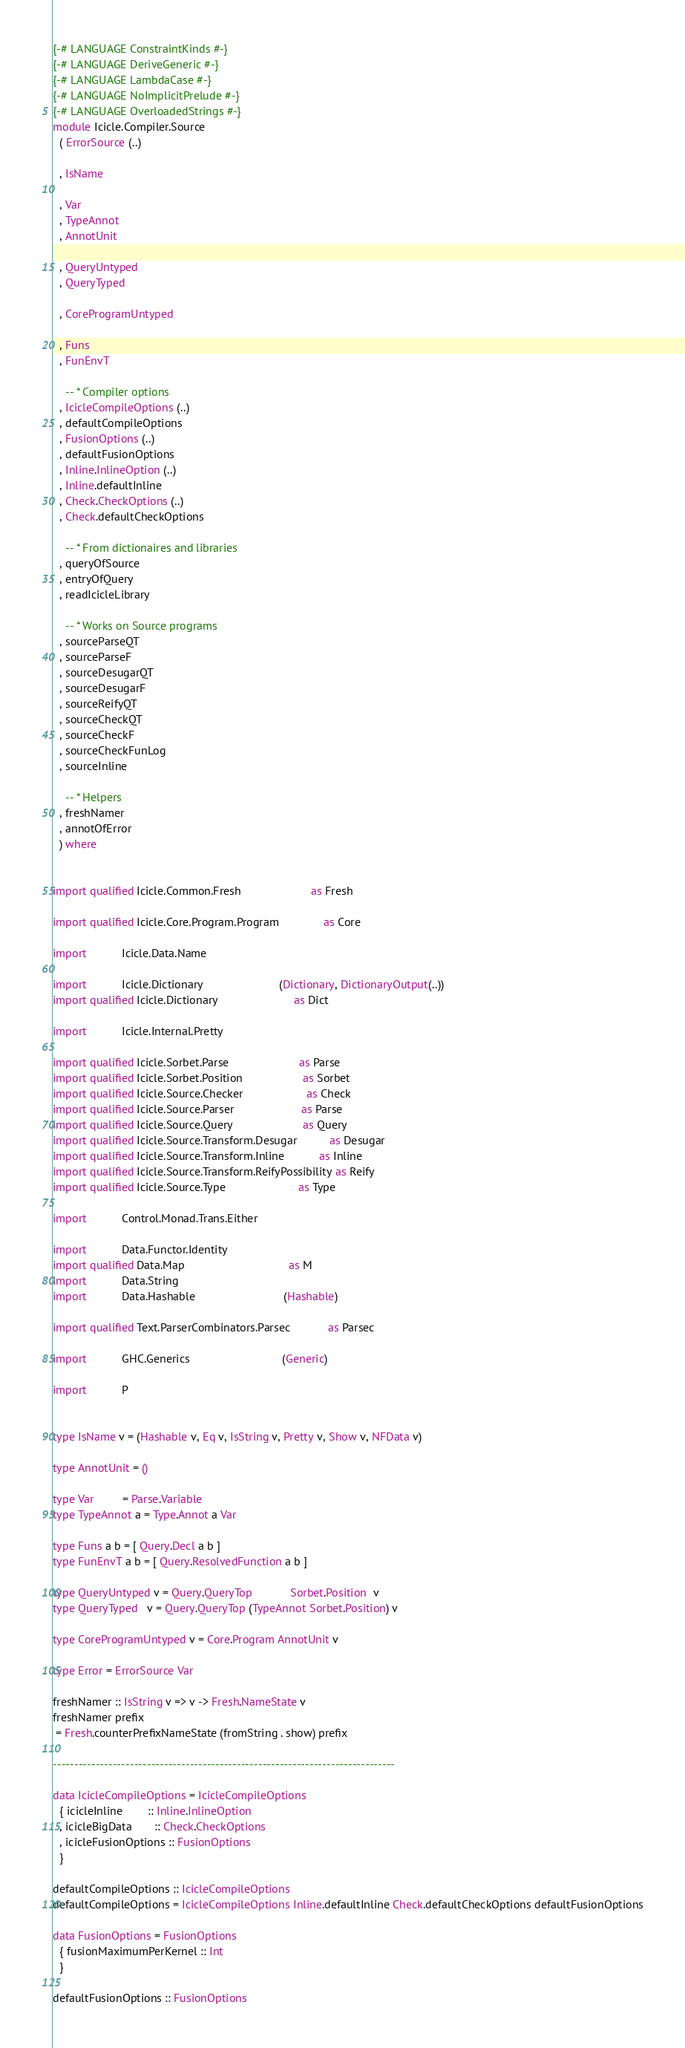Convert code to text. <code><loc_0><loc_0><loc_500><loc_500><_Haskell_>{-# LANGUAGE ConstraintKinds #-}
{-# LANGUAGE DeriveGeneric #-}
{-# LANGUAGE LambdaCase #-}
{-# LANGUAGE NoImplicitPrelude #-}
{-# LANGUAGE OverloadedStrings #-}
module Icicle.Compiler.Source
  ( ErrorSource (..)

  , IsName

  , Var
  , TypeAnnot
  , AnnotUnit

  , QueryUntyped
  , QueryTyped

  , CoreProgramUntyped

  , Funs
  , FunEnvT

    -- * Compiler options
  , IcicleCompileOptions (..)
  , defaultCompileOptions
  , FusionOptions (..)
  , defaultFusionOptions
  , Inline.InlineOption (..)
  , Inline.defaultInline
  , Check.CheckOptions (..)
  , Check.defaultCheckOptions

    -- * From dictionaires and libraries
  , queryOfSource
  , entryOfQuery
  , readIcicleLibrary

    -- * Works on Source programs
  , sourceParseQT
  , sourceParseF
  , sourceDesugarQT
  , sourceDesugarF
  , sourceReifyQT
  , sourceCheckQT
  , sourceCheckF
  , sourceCheckFunLog
  , sourceInline

    -- * Helpers
  , freshNamer
  , annotOfError
  ) where


import qualified Icicle.Common.Fresh                      as Fresh

import qualified Icicle.Core.Program.Program              as Core

import           Icicle.Data.Name

import           Icicle.Dictionary                        (Dictionary, DictionaryOutput(..))
import qualified Icicle.Dictionary                        as Dict

import           Icicle.Internal.Pretty

import qualified Icicle.Sorbet.Parse                      as Parse
import qualified Icicle.Sorbet.Position                   as Sorbet
import qualified Icicle.Source.Checker                    as Check
import qualified Icicle.Source.Parser                     as Parse
import qualified Icicle.Source.Query                      as Query
import qualified Icicle.Source.Transform.Desugar          as Desugar
import qualified Icicle.Source.Transform.Inline           as Inline
import qualified Icicle.Source.Transform.ReifyPossibility as Reify
import qualified Icicle.Source.Type                       as Type

import           Control.Monad.Trans.Either

import           Data.Functor.Identity
import qualified Data.Map                                 as M
import           Data.String
import           Data.Hashable                            (Hashable)

import qualified Text.ParserCombinators.Parsec            as Parsec

import           GHC.Generics                             (Generic)

import           P


type IsName v = (Hashable v, Eq v, IsString v, Pretty v, Show v, NFData v)

type AnnotUnit = ()

type Var         = Parse.Variable
type TypeAnnot a = Type.Annot a Var

type Funs a b = [ Query.Decl a b ]
type FunEnvT a b = [ Query.ResolvedFunction a b ]

type QueryUntyped v = Query.QueryTop            Sorbet.Position  v
type QueryTyped   v = Query.QueryTop (TypeAnnot Sorbet.Position) v

type CoreProgramUntyped v = Core.Program AnnotUnit v

type Error = ErrorSource Var

freshNamer :: IsString v => v -> Fresh.NameState v
freshNamer prefix
 = Fresh.counterPrefixNameState (fromString . show) prefix

--------------------------------------------------------------------------------

data IcicleCompileOptions = IcicleCompileOptions
  { icicleInline        :: Inline.InlineOption
  , icicleBigData       :: Check.CheckOptions
  , icicleFusionOptions :: FusionOptions
  }

defaultCompileOptions :: IcicleCompileOptions
defaultCompileOptions = IcicleCompileOptions Inline.defaultInline Check.defaultCheckOptions defaultFusionOptions

data FusionOptions = FusionOptions
  { fusionMaximumPerKernel :: Int
  }

defaultFusionOptions :: FusionOptions</code> 